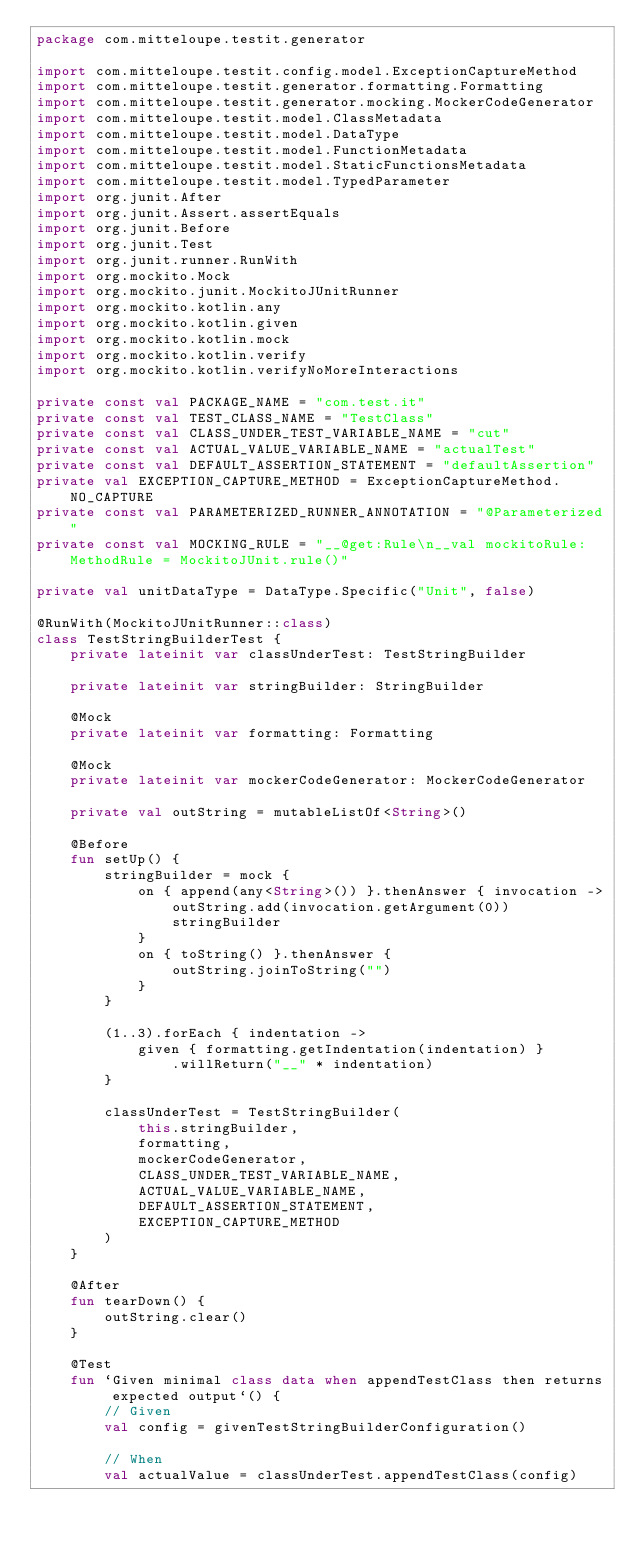<code> <loc_0><loc_0><loc_500><loc_500><_Kotlin_>package com.mitteloupe.testit.generator

import com.mitteloupe.testit.config.model.ExceptionCaptureMethod
import com.mitteloupe.testit.generator.formatting.Formatting
import com.mitteloupe.testit.generator.mocking.MockerCodeGenerator
import com.mitteloupe.testit.model.ClassMetadata
import com.mitteloupe.testit.model.DataType
import com.mitteloupe.testit.model.FunctionMetadata
import com.mitteloupe.testit.model.StaticFunctionsMetadata
import com.mitteloupe.testit.model.TypedParameter
import org.junit.After
import org.junit.Assert.assertEquals
import org.junit.Before
import org.junit.Test
import org.junit.runner.RunWith
import org.mockito.Mock
import org.mockito.junit.MockitoJUnitRunner
import org.mockito.kotlin.any
import org.mockito.kotlin.given
import org.mockito.kotlin.mock
import org.mockito.kotlin.verify
import org.mockito.kotlin.verifyNoMoreInteractions

private const val PACKAGE_NAME = "com.test.it"
private const val TEST_CLASS_NAME = "TestClass"
private const val CLASS_UNDER_TEST_VARIABLE_NAME = "cut"
private const val ACTUAL_VALUE_VARIABLE_NAME = "actualTest"
private const val DEFAULT_ASSERTION_STATEMENT = "defaultAssertion"
private val EXCEPTION_CAPTURE_METHOD = ExceptionCaptureMethod.NO_CAPTURE
private const val PARAMETERIZED_RUNNER_ANNOTATION = "@Parameterized"
private const val MOCKING_RULE = "__@get:Rule\n__val mockitoRule: MethodRule = MockitoJUnit.rule()"

private val unitDataType = DataType.Specific("Unit", false)

@RunWith(MockitoJUnitRunner::class)
class TestStringBuilderTest {
    private lateinit var classUnderTest: TestStringBuilder

    private lateinit var stringBuilder: StringBuilder

    @Mock
    private lateinit var formatting: Formatting

    @Mock
    private lateinit var mockerCodeGenerator: MockerCodeGenerator

    private val outString = mutableListOf<String>()

    @Before
    fun setUp() {
        stringBuilder = mock {
            on { append(any<String>()) }.thenAnswer { invocation ->
                outString.add(invocation.getArgument(0))
                stringBuilder
            }
            on { toString() }.thenAnswer {
                outString.joinToString("")
            }
        }

        (1..3).forEach { indentation ->
            given { formatting.getIndentation(indentation) }
                .willReturn("__" * indentation)
        }

        classUnderTest = TestStringBuilder(
            this.stringBuilder,
            formatting,
            mockerCodeGenerator,
            CLASS_UNDER_TEST_VARIABLE_NAME,
            ACTUAL_VALUE_VARIABLE_NAME,
            DEFAULT_ASSERTION_STATEMENT,
            EXCEPTION_CAPTURE_METHOD
        )
    }

    @After
    fun tearDown() {
        outString.clear()
    }

    @Test
    fun `Given minimal class data when appendTestClass then returns expected output`() {
        // Given
        val config = givenTestStringBuilderConfiguration()

        // When
        val actualValue = classUnderTest.appendTestClass(config)
</code> 